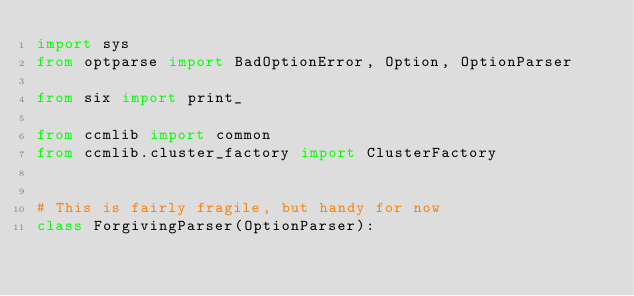<code> <loc_0><loc_0><loc_500><loc_500><_Python_>import sys
from optparse import BadOptionError, Option, OptionParser

from six import print_

from ccmlib import common
from ccmlib.cluster_factory import ClusterFactory


# This is fairly fragile, but handy for now
class ForgivingParser(OptionParser):
</code> 